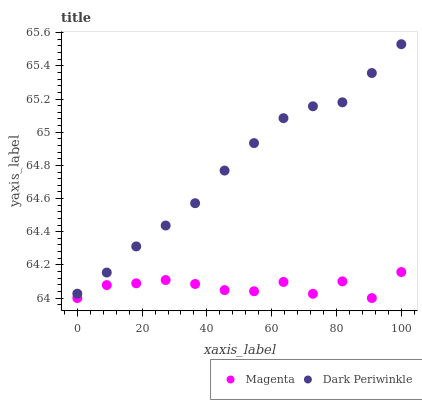Does Magenta have the minimum area under the curve?
Answer yes or no. Yes. Does Dark Periwinkle have the maximum area under the curve?
Answer yes or no. Yes. Does Dark Periwinkle have the minimum area under the curve?
Answer yes or no. No. Is Dark Periwinkle the smoothest?
Answer yes or no. Yes. Is Magenta the roughest?
Answer yes or no. Yes. Is Dark Periwinkle the roughest?
Answer yes or no. No. Does Magenta have the lowest value?
Answer yes or no. Yes. Does Dark Periwinkle have the lowest value?
Answer yes or no. No. Does Dark Periwinkle have the highest value?
Answer yes or no. Yes. Is Magenta less than Dark Periwinkle?
Answer yes or no. Yes. Is Dark Periwinkle greater than Magenta?
Answer yes or no. Yes. Does Magenta intersect Dark Periwinkle?
Answer yes or no. No. 